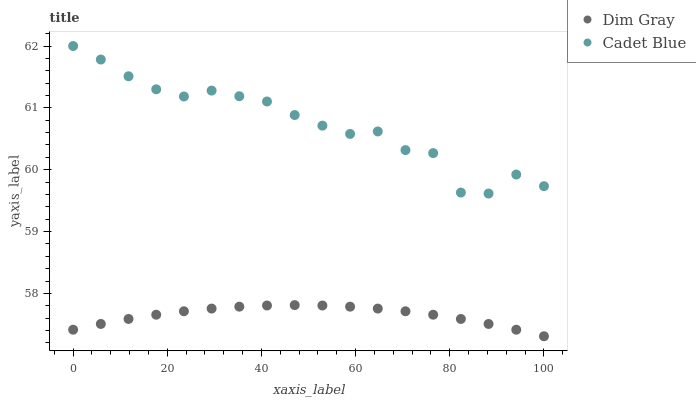Does Dim Gray have the minimum area under the curve?
Answer yes or no. Yes. Does Cadet Blue have the maximum area under the curve?
Answer yes or no. Yes. Does Dim Gray have the maximum area under the curve?
Answer yes or no. No. Is Dim Gray the smoothest?
Answer yes or no. Yes. Is Cadet Blue the roughest?
Answer yes or no. Yes. Is Dim Gray the roughest?
Answer yes or no. No. Does Dim Gray have the lowest value?
Answer yes or no. Yes. Does Cadet Blue have the highest value?
Answer yes or no. Yes. Does Dim Gray have the highest value?
Answer yes or no. No. Is Dim Gray less than Cadet Blue?
Answer yes or no. Yes. Is Cadet Blue greater than Dim Gray?
Answer yes or no. Yes. Does Dim Gray intersect Cadet Blue?
Answer yes or no. No. 